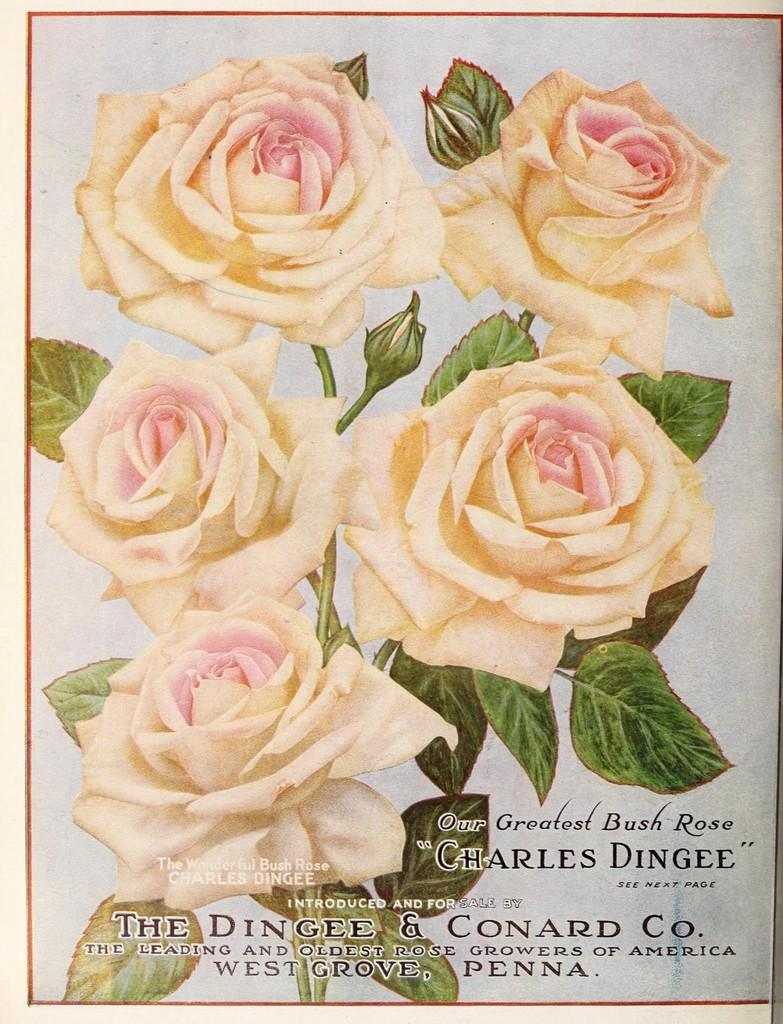What type of visual content is depicted in the image? The image is a poster. What is the main subject of the poster? There is a plant in the poster. How many rose flowers are on the plant? The plant has five rose flowers. What are the characteristics of the rose flowers? The rose flowers have buds and leaves, and they are white and pinkish in color. What else can be seen on the poster besides the plant? There are letters on the poster. How many clover leaves can be seen on the poster? There are no clover leaves present in the image; it features a plant with rose flowers. What word is written on the poster to indicate that people should stop? There is no indication of a stop or any specific word in the image; it is a poster with a plant and letters. 